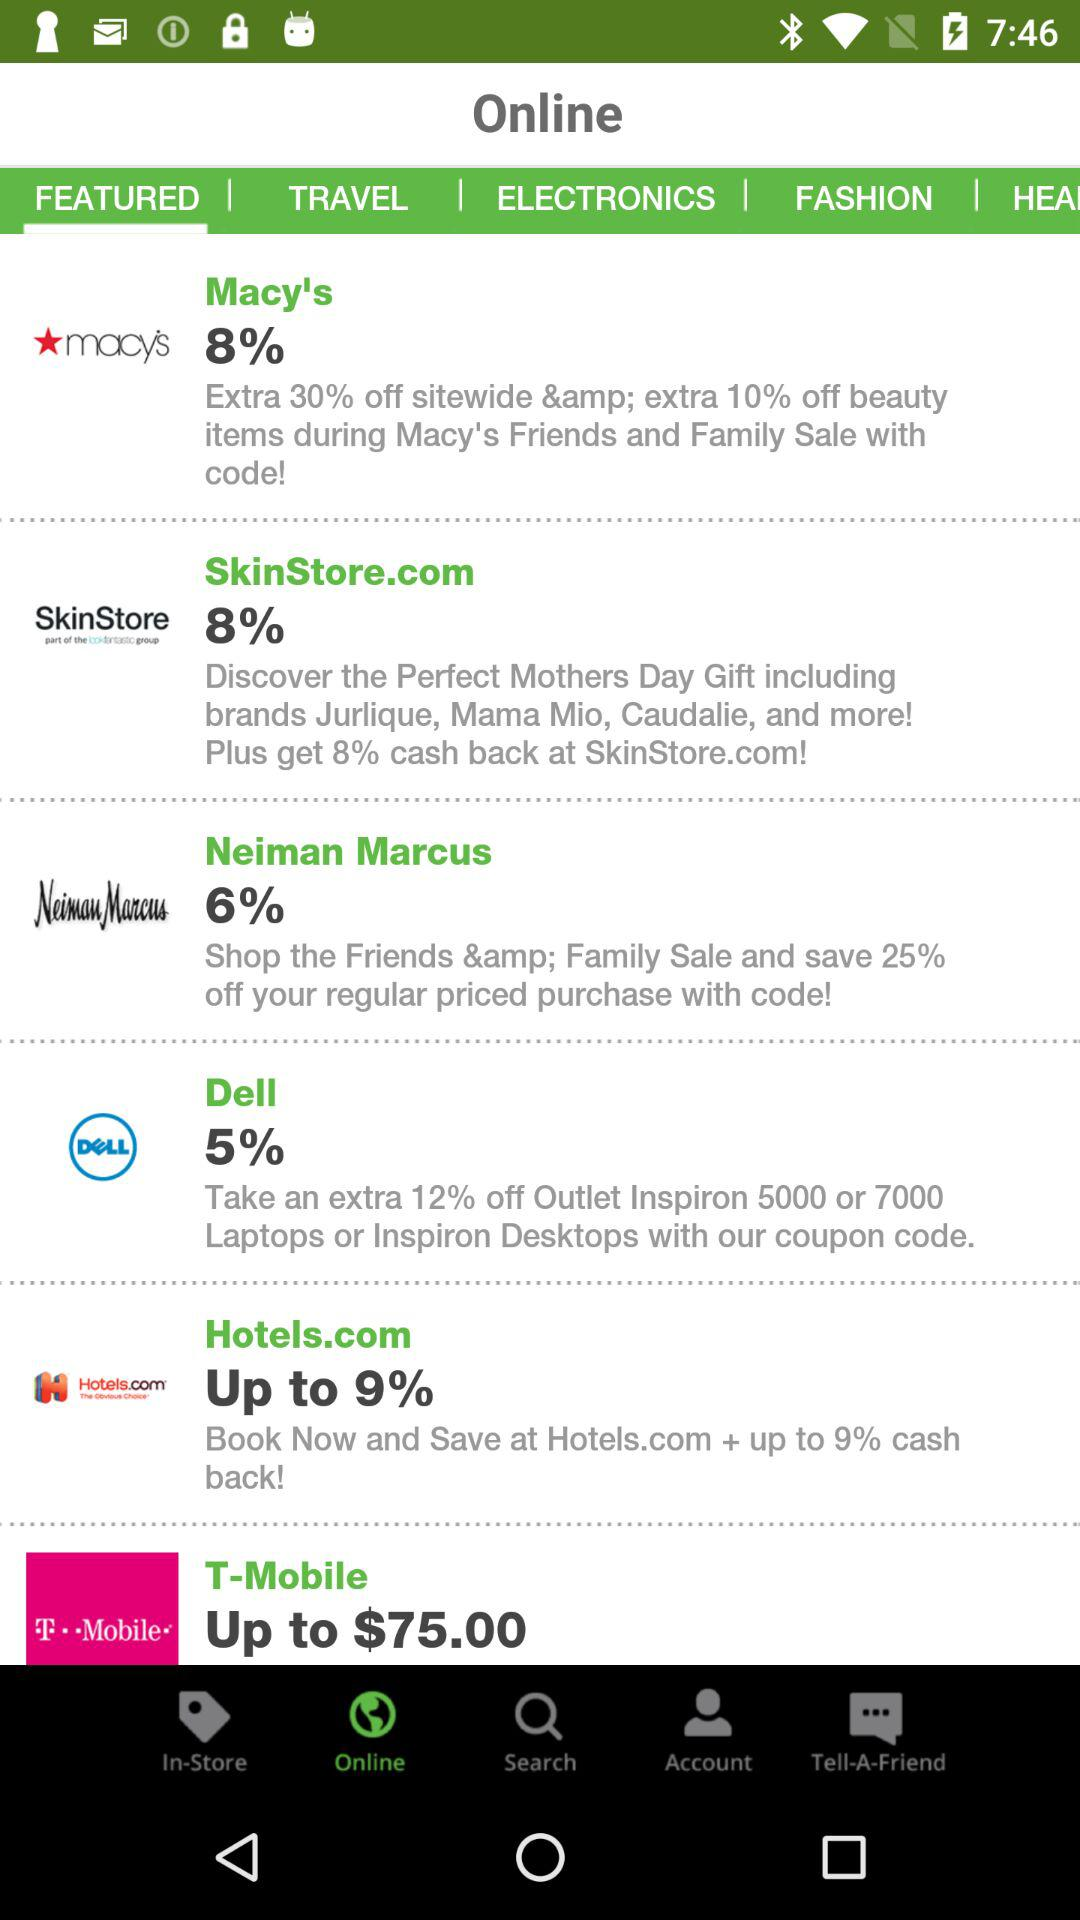How much cashback does SkinStore.com offer? SkinStore.com offers 8% cashback. 